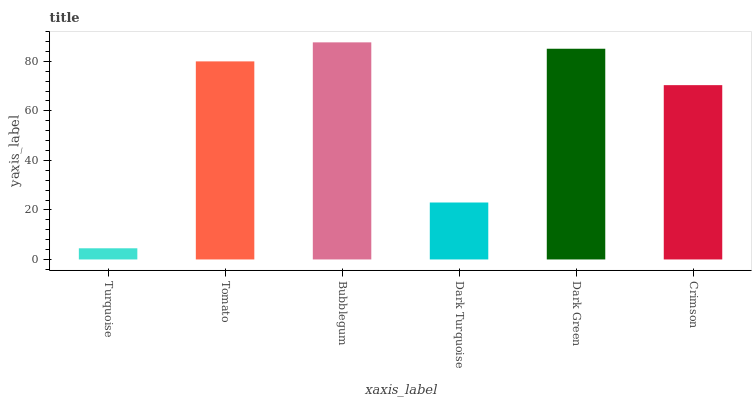Is Turquoise the minimum?
Answer yes or no. Yes. Is Bubblegum the maximum?
Answer yes or no. Yes. Is Tomato the minimum?
Answer yes or no. No. Is Tomato the maximum?
Answer yes or no. No. Is Tomato greater than Turquoise?
Answer yes or no. Yes. Is Turquoise less than Tomato?
Answer yes or no. Yes. Is Turquoise greater than Tomato?
Answer yes or no. No. Is Tomato less than Turquoise?
Answer yes or no. No. Is Tomato the high median?
Answer yes or no. Yes. Is Crimson the low median?
Answer yes or no. Yes. Is Turquoise the high median?
Answer yes or no. No. Is Turquoise the low median?
Answer yes or no. No. 